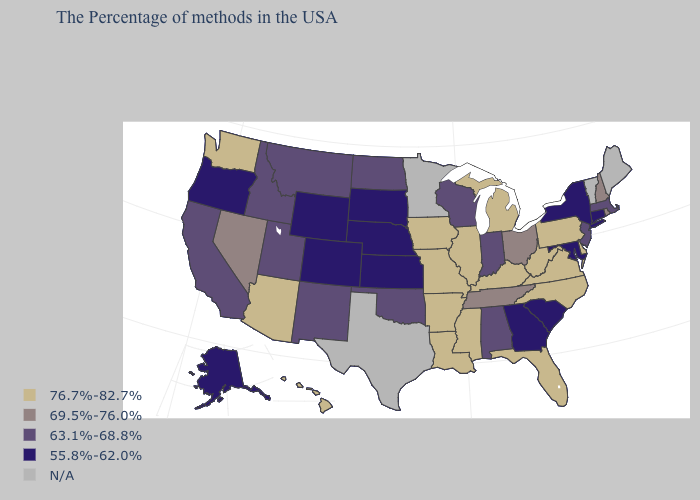Name the states that have a value in the range N/A?
Give a very brief answer. Maine, Vermont, Minnesota, Texas. Among the states that border Delaware , does New Jersey have the lowest value?
Concise answer only. No. What is the lowest value in the USA?
Give a very brief answer. 55.8%-62.0%. Which states have the highest value in the USA?
Be succinct. Delaware, Pennsylvania, Virginia, North Carolina, West Virginia, Florida, Michigan, Kentucky, Illinois, Mississippi, Louisiana, Missouri, Arkansas, Iowa, Arizona, Washington, Hawaii. How many symbols are there in the legend?
Short answer required. 5. What is the value of West Virginia?
Give a very brief answer. 76.7%-82.7%. Name the states that have a value in the range N/A?
Short answer required. Maine, Vermont, Minnesota, Texas. Name the states that have a value in the range 63.1%-68.8%?
Be succinct. Massachusetts, New Jersey, Indiana, Alabama, Wisconsin, Oklahoma, North Dakota, New Mexico, Utah, Montana, Idaho, California. Is the legend a continuous bar?
Quick response, please. No. Does Arizona have the lowest value in the West?
Quick response, please. No. What is the value of New York?
Be succinct. 55.8%-62.0%. What is the value of New Hampshire?
Short answer required. 69.5%-76.0%. Name the states that have a value in the range 69.5%-76.0%?
Be succinct. Rhode Island, New Hampshire, Ohio, Tennessee, Nevada. Name the states that have a value in the range 55.8%-62.0%?
Answer briefly. Connecticut, New York, Maryland, South Carolina, Georgia, Kansas, Nebraska, South Dakota, Wyoming, Colorado, Oregon, Alaska. Does the map have missing data?
Answer briefly. Yes. 